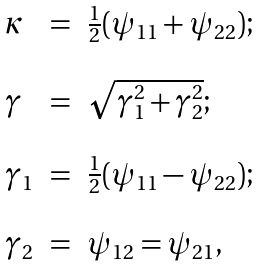<formula> <loc_0><loc_0><loc_500><loc_500>\begin{array} { l l l } \kappa & = & \frac { 1 } { 2 } ( \psi _ { 1 1 } + \psi _ { 2 2 } ) ; \\ & & \\ \gamma & = & \sqrt { \gamma _ { 1 } ^ { 2 } + \gamma _ { 2 } ^ { 2 } } ; \\ & & \\ \gamma _ { 1 } & = & \frac { 1 } { 2 } ( \psi _ { 1 1 } - \psi _ { 2 2 } ) ; \\ & & \\ \gamma _ { 2 } & = & \psi _ { 1 2 } = \psi _ { 2 1 } , \\ \end{array}</formula> 